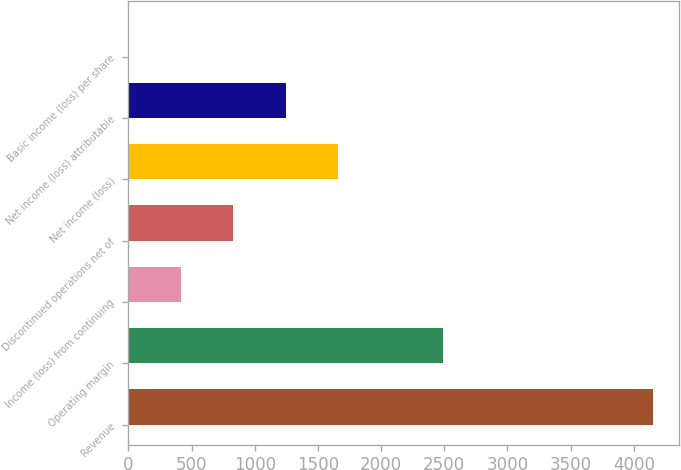Convert chart. <chart><loc_0><loc_0><loc_500><loc_500><bar_chart><fcel>Revenue<fcel>Operating margin<fcel>Income (loss) from continuing<fcel>Discontinued operations net of<fcel>Net income (loss)<fcel>Net income (loss) attributable<fcel>Basic income (loss) per share<nl><fcel>4150<fcel>2490.05<fcel>415.1<fcel>830.09<fcel>1660.07<fcel>1245.08<fcel>0.11<nl></chart> 